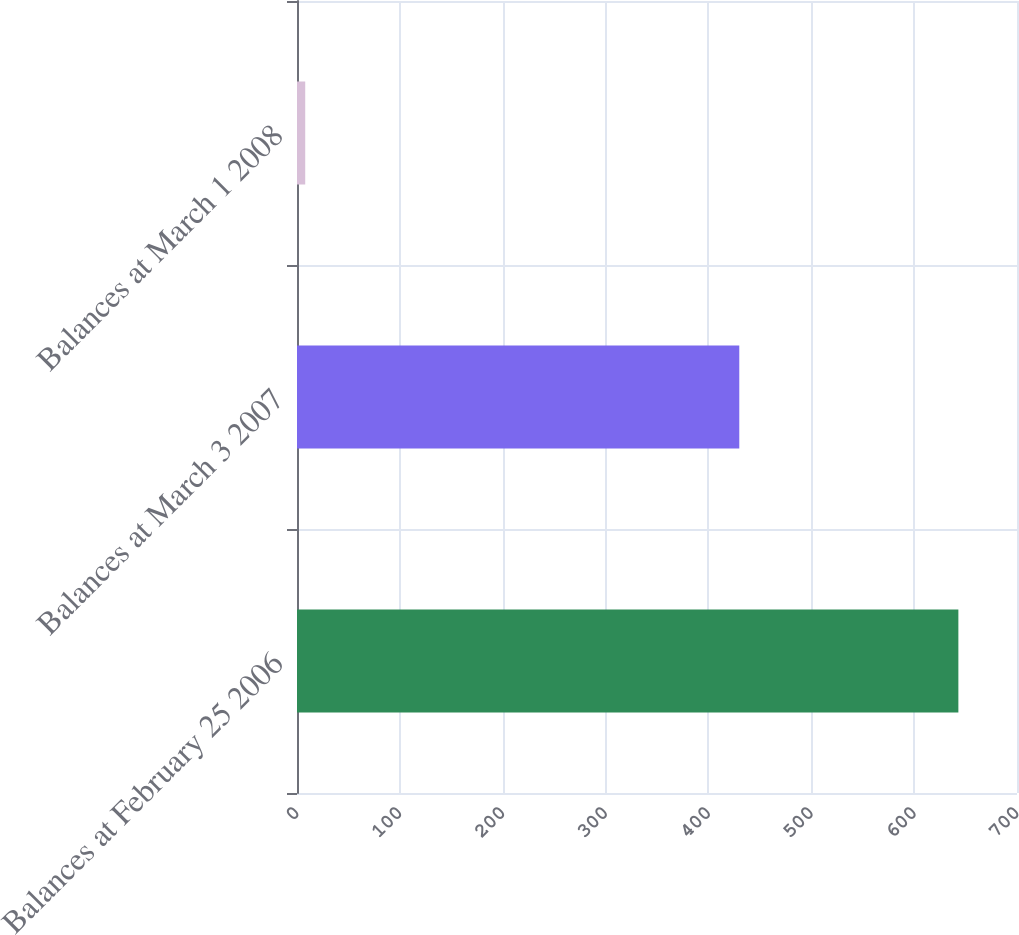Convert chart to OTSL. <chart><loc_0><loc_0><loc_500><loc_500><bar_chart><fcel>Balances at February 25 2006<fcel>Balances at March 3 2007<fcel>Balances at March 1 2008<nl><fcel>643<fcel>430<fcel>8<nl></chart> 